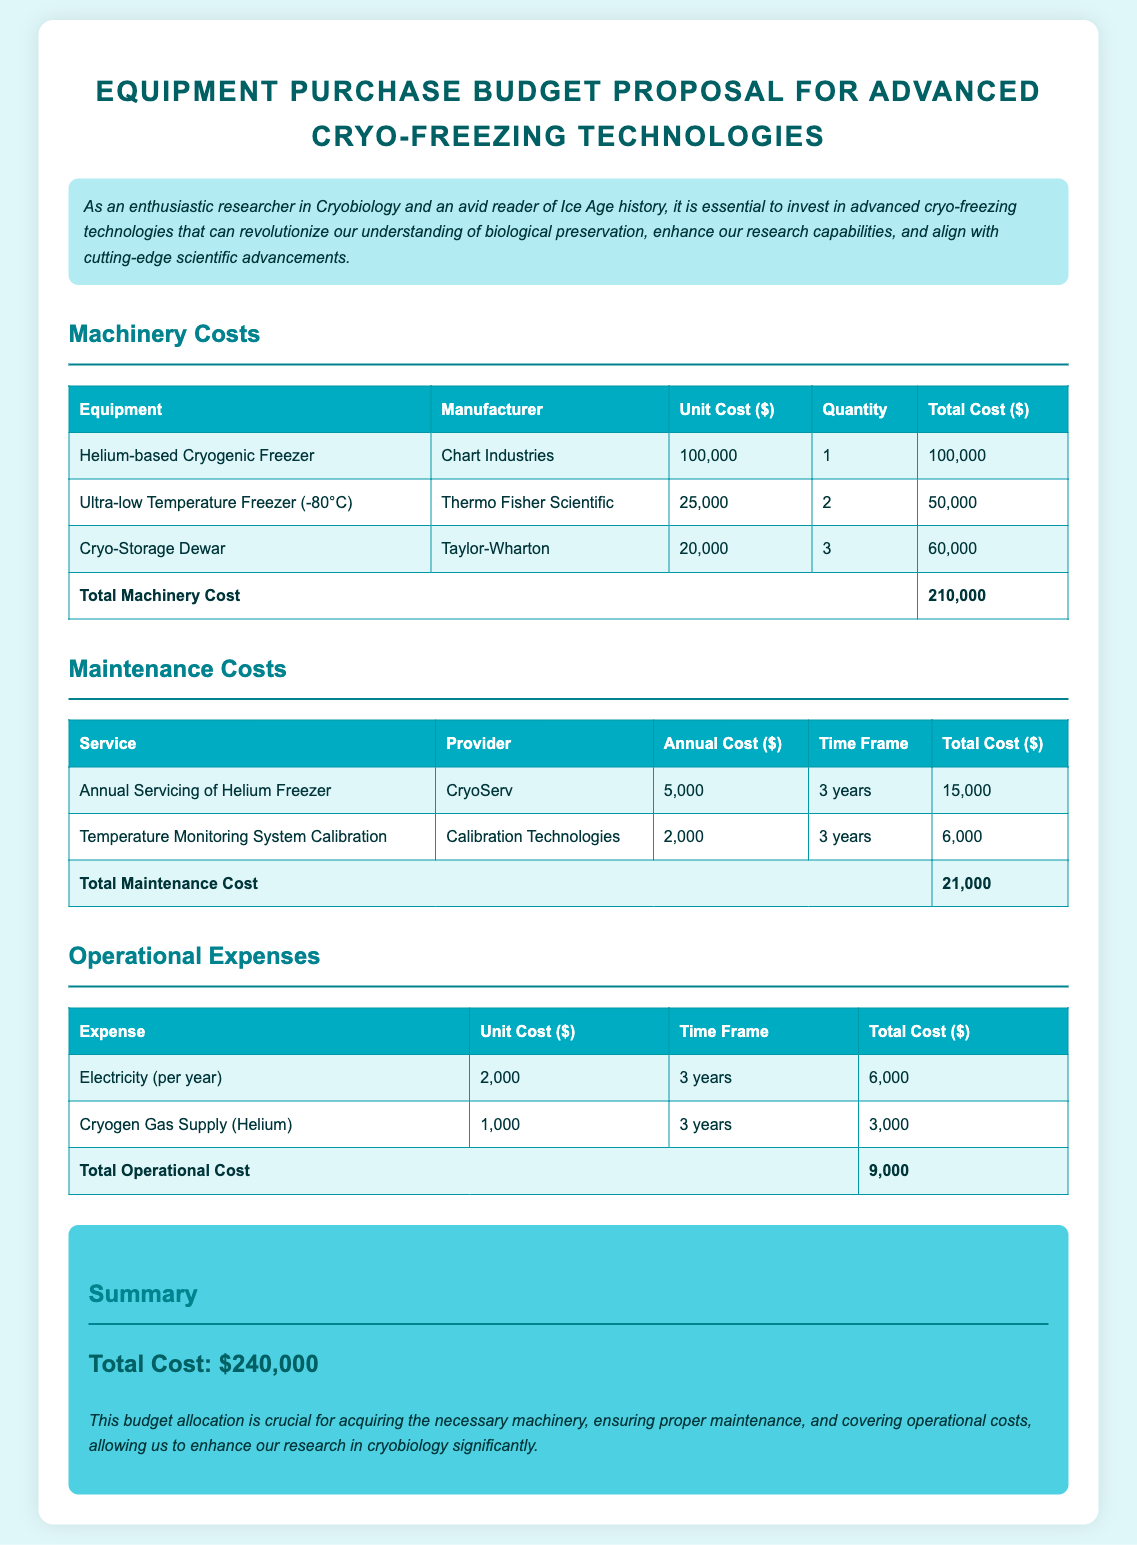What is the total machinery cost? The total machinery cost is found by summing the individual equipment costs listed in the machinery section of the document.
Answer: 210,000 Who is the manufacturer of the Helium-based Cryogenic Freezer? The document states that the manufacturer of the Helium-based Cryogenic Freezer is Chart Industries.
Answer: Chart Industries How much does annual servicing of the Helium Freezer cost? The document specifies the annual cost for servicing the Helium Freezer, which is mentioned under the maintenance costs section.
Answer: 5,000 What is the time frame for the Temperature Monitoring System Calibration? The time frame is indicated in the maintenance costs section, showing the duration for which the service is needed.
Answer: 3 years What is the total operational cost? The total operational cost is the sum of the individual operational expenses listed in the operational expenses section of the document.
Answer: 9,000 What equipment has a unit cost of $20,000? The document lists the Cryo-Storage Dewar with its corresponding unit cost in the machinery section.
Answer: Cryo-Storage Dewar Who is responsible for providing the Service for Annual Servicing of Helium Freezer? The provider of the service is mentioned alongside the annual servicing details in the maintenance costs section.
Answer: CryoServ What is the total cost for maintenance services over the 3-year period? The total cost for maintenance services can be calculated as per the maintenance table presented in the document.
Answer: 21,000 What are the total costs, including machinery, maintenance, and operational expenses? The total costs are summarized at the end of the document, combining all categories of expenses.
Answer: 240,000 